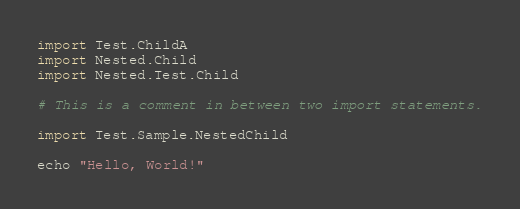<code> <loc_0><loc_0><loc_500><loc_500><_Nim_>import Test.ChildA
import Nested.Child
import Nested.Test.Child

# This is a comment in between two import statements.

import Test.Sample.NestedChild

echo "Hello, World!"
</code> 